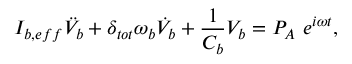Convert formula to latex. <formula><loc_0><loc_0><loc_500><loc_500>I _ { b , e f f } \ddot { V } _ { b } + \delta _ { t o t } \omega _ { b } \dot { V } _ { b } + \frac { 1 } { C _ { b } } V _ { b } = P _ { A } e ^ { i \omega t } ,</formula> 